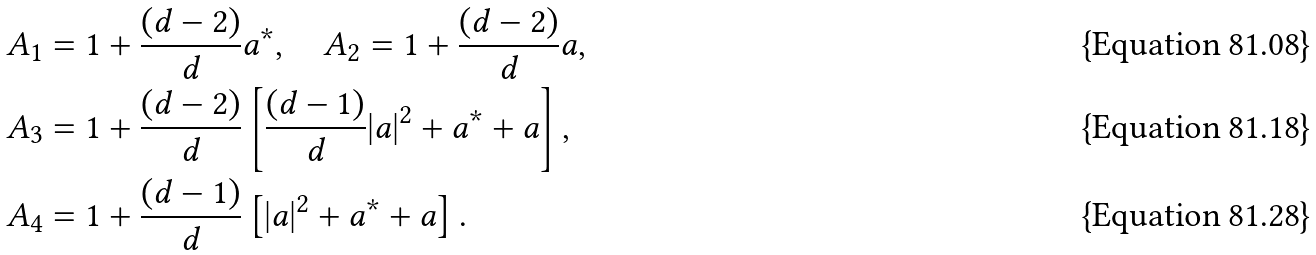<formula> <loc_0><loc_0><loc_500><loc_500>A _ { 1 } & = 1 + \frac { ( d - 2 ) } { d } a ^ { * } , \quad A _ { 2 } = 1 + \frac { ( d - 2 ) } { d } a , \\ A _ { 3 } & = 1 + \frac { ( d - 2 ) } { d } \left [ \frac { ( d - 1 ) } { d } | a | ^ { 2 } + a ^ { * } + a \right ] , \\ A _ { 4 } & = 1 + \frac { ( d - 1 ) } { d } \left [ | a | ^ { 2 } + a ^ { * } + a \right ] .</formula> 